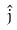Convert formula to latex. <formula><loc_0><loc_0><loc_500><loc_500>\hat { j }</formula> 